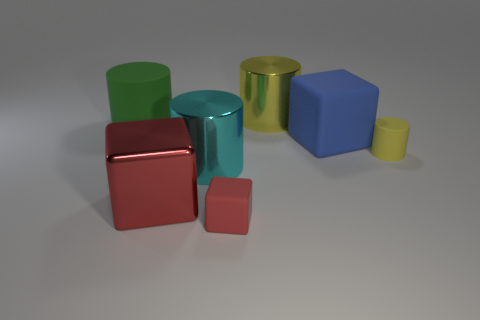Subtract all cyan cylinders. How many cylinders are left? 3 Subtract all large cubes. How many cubes are left? 1 Add 1 large red matte spheres. How many objects exist? 8 Add 1 large metallic blocks. How many large metallic blocks are left? 2 Add 1 large rubber objects. How many large rubber objects exist? 3 Subtract 1 blue cubes. How many objects are left? 6 Subtract all cubes. How many objects are left? 4 Subtract 2 blocks. How many blocks are left? 1 Subtract all green cylinders. Subtract all gray cubes. How many cylinders are left? 3 Subtract all green cylinders. How many green cubes are left? 0 